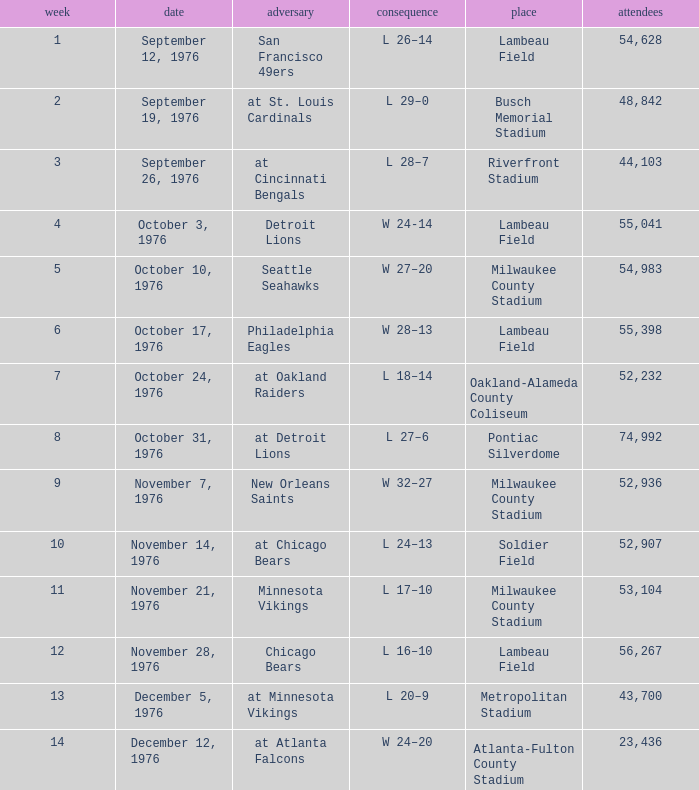What is the average attendance for the game on September 26, 1976? 44103.0. 